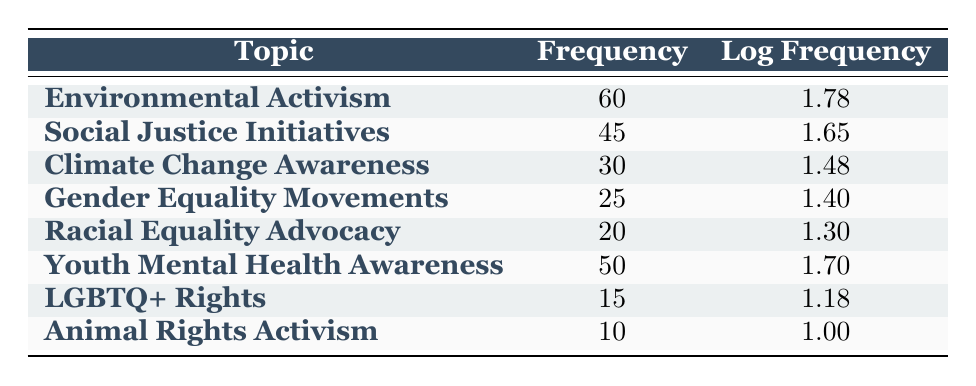What is the frequency of counseling sessions related to Environmental Activism? The table clearly lists "Environmental Activism" with a frequency of 60 sessions.
Answer: 60 Which topic has the least frequency of counseling sessions? Looking through the table, "Animal Rights Activism" has the lowest frequency at 10 sessions.
Answer: Animal Rights Activism What is the log frequency for Social Justice Initiatives? The table indicates that the log frequency for "Social Justice Initiatives" is 1.65.
Answer: 1.65 What is the total frequency of counseling sessions for Climate Change Awareness and Gender Equality Movements combined? The frequency for "Climate Change Awareness" is 30 and for "Gender Equality Movements" it is 25. Adding these together gives us 30 + 25 = 55.
Answer: 55 Is the frequency of counseling sessions for Youth Mental Health Awareness greater than that for Racial Equality Advocacy? "Youth Mental Health Awareness" has a frequency of 50, while "Racial Equality Advocacy" has a frequency of 20. Since 50 is greater than 20, the statement is true.
Answer: Yes What is the difference in log frequency between the topic with the highest frequency and the topic with the lowest frequency? The highest frequency is for "Environmental Activism" with a log frequency of 1.78, and the lowest is for "Animal Rights Activism" with a log frequency of 1.00. The difference is 1.78 - 1.00 = 0.78.
Answer: 0.78 Which topics have a frequency greater than 30? From the table, the topics with a frequency greater than 30 are "Environmental Activism" (60), "Youth Mental Health Awareness" (50), and "Social Justice Initiatives" (45).
Answer: Environmental Activism, Youth Mental Health Awareness, Social Justice Initiatives What is the average frequency of all the counseling sessions listed in the table? The frequencies are 60, 45, 30, 25, 20, 50, 15, and 10. Summing these gives a total of 255. There are 8 topics, so the average is 255 / 8 = 31.875.
Answer: 31.875 Are there more counseling sessions for LGBTQ+ Rights than for Animal Rights Activism? The table shows 15 sessions for "LGBTQ+ Rights" and 10 for "Animal Rights Activism." Since 15 is more than 10, the statement is true.
Answer: Yes 